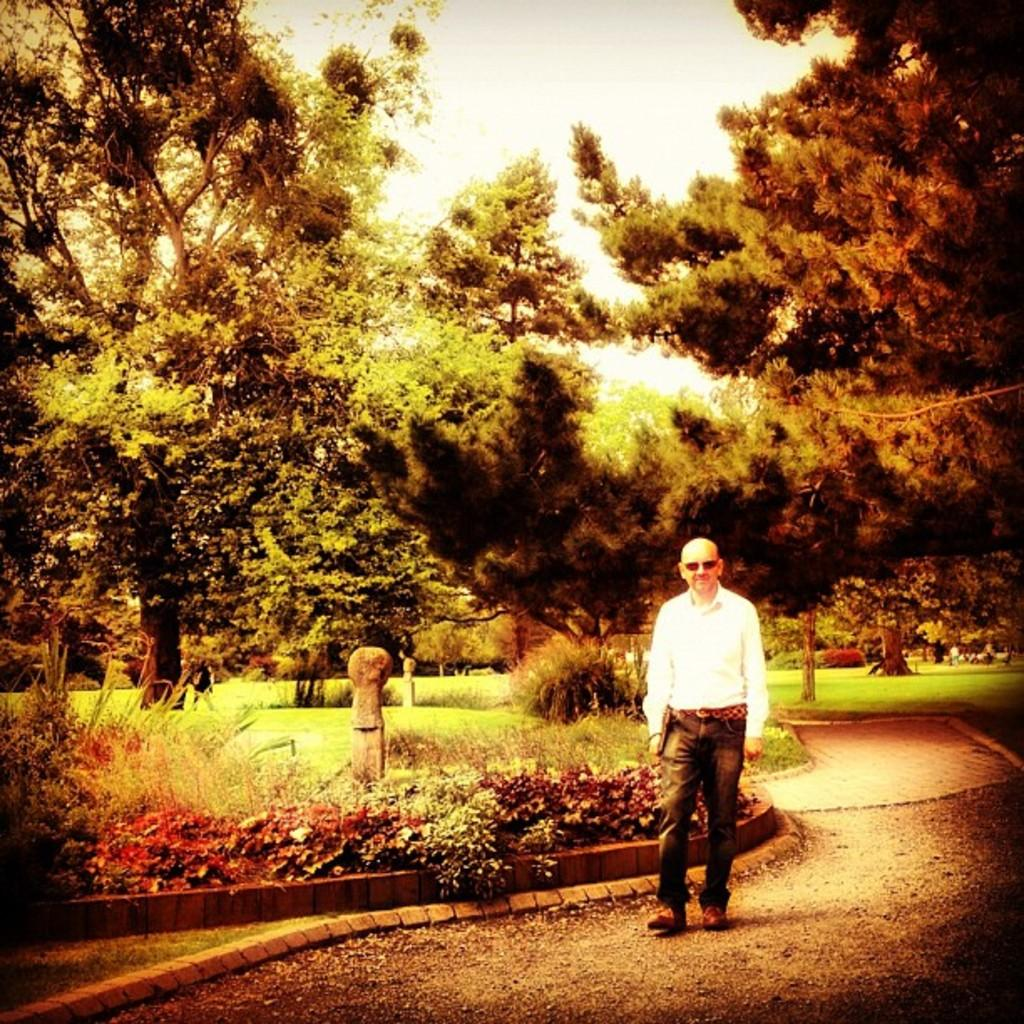What is the appearance of the person in the image? There is a bald-headed person in the image. What is the person doing in the image? The person is walking on a path. What type of natural elements can be seen in the image? There are plants and trees in the image. What scientific discoveries is the person making while walking on the path in the image? There is no indication in the image that the person is making any scientific discoveries while walking on the path. 